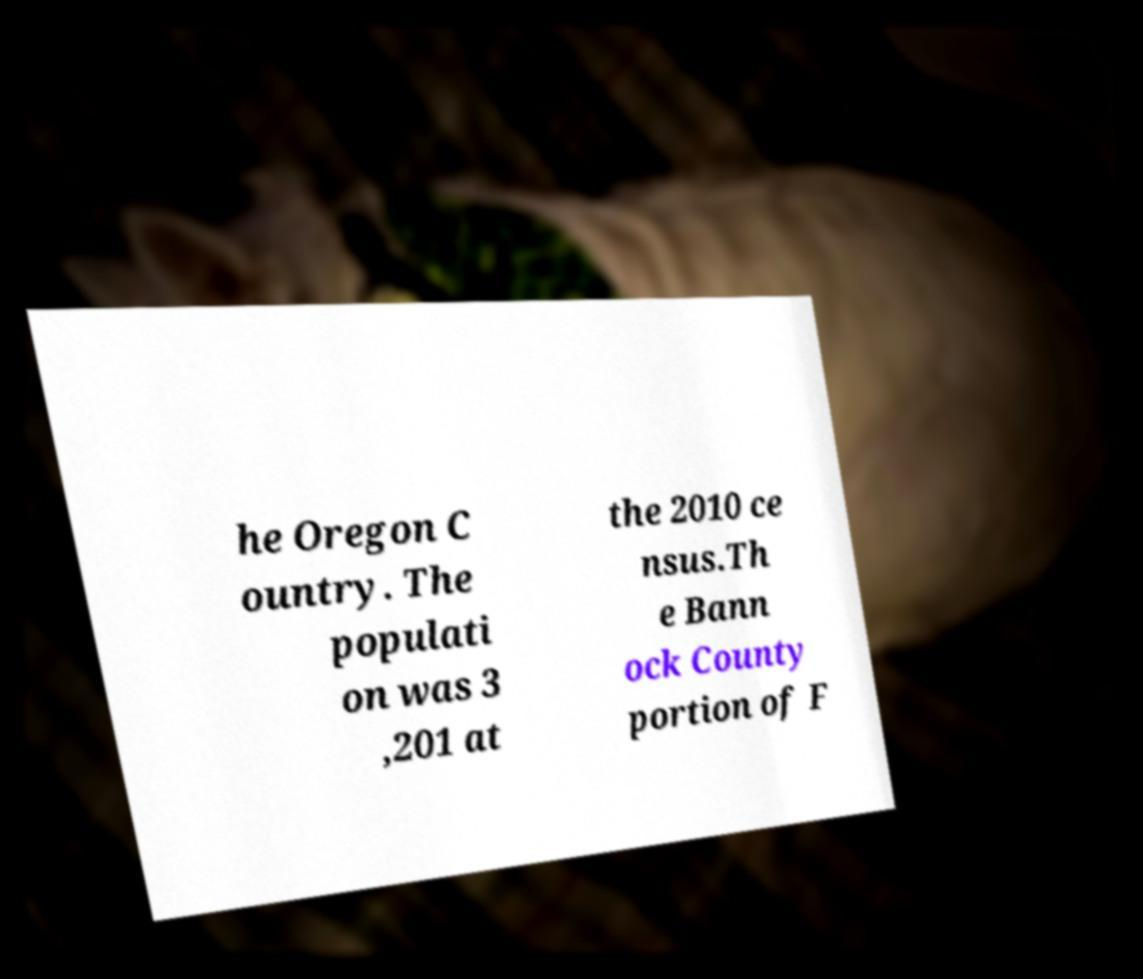Please read and relay the text visible in this image. What does it say? he Oregon C ountry. The populati on was 3 ,201 at the 2010 ce nsus.Th e Bann ock County portion of F 